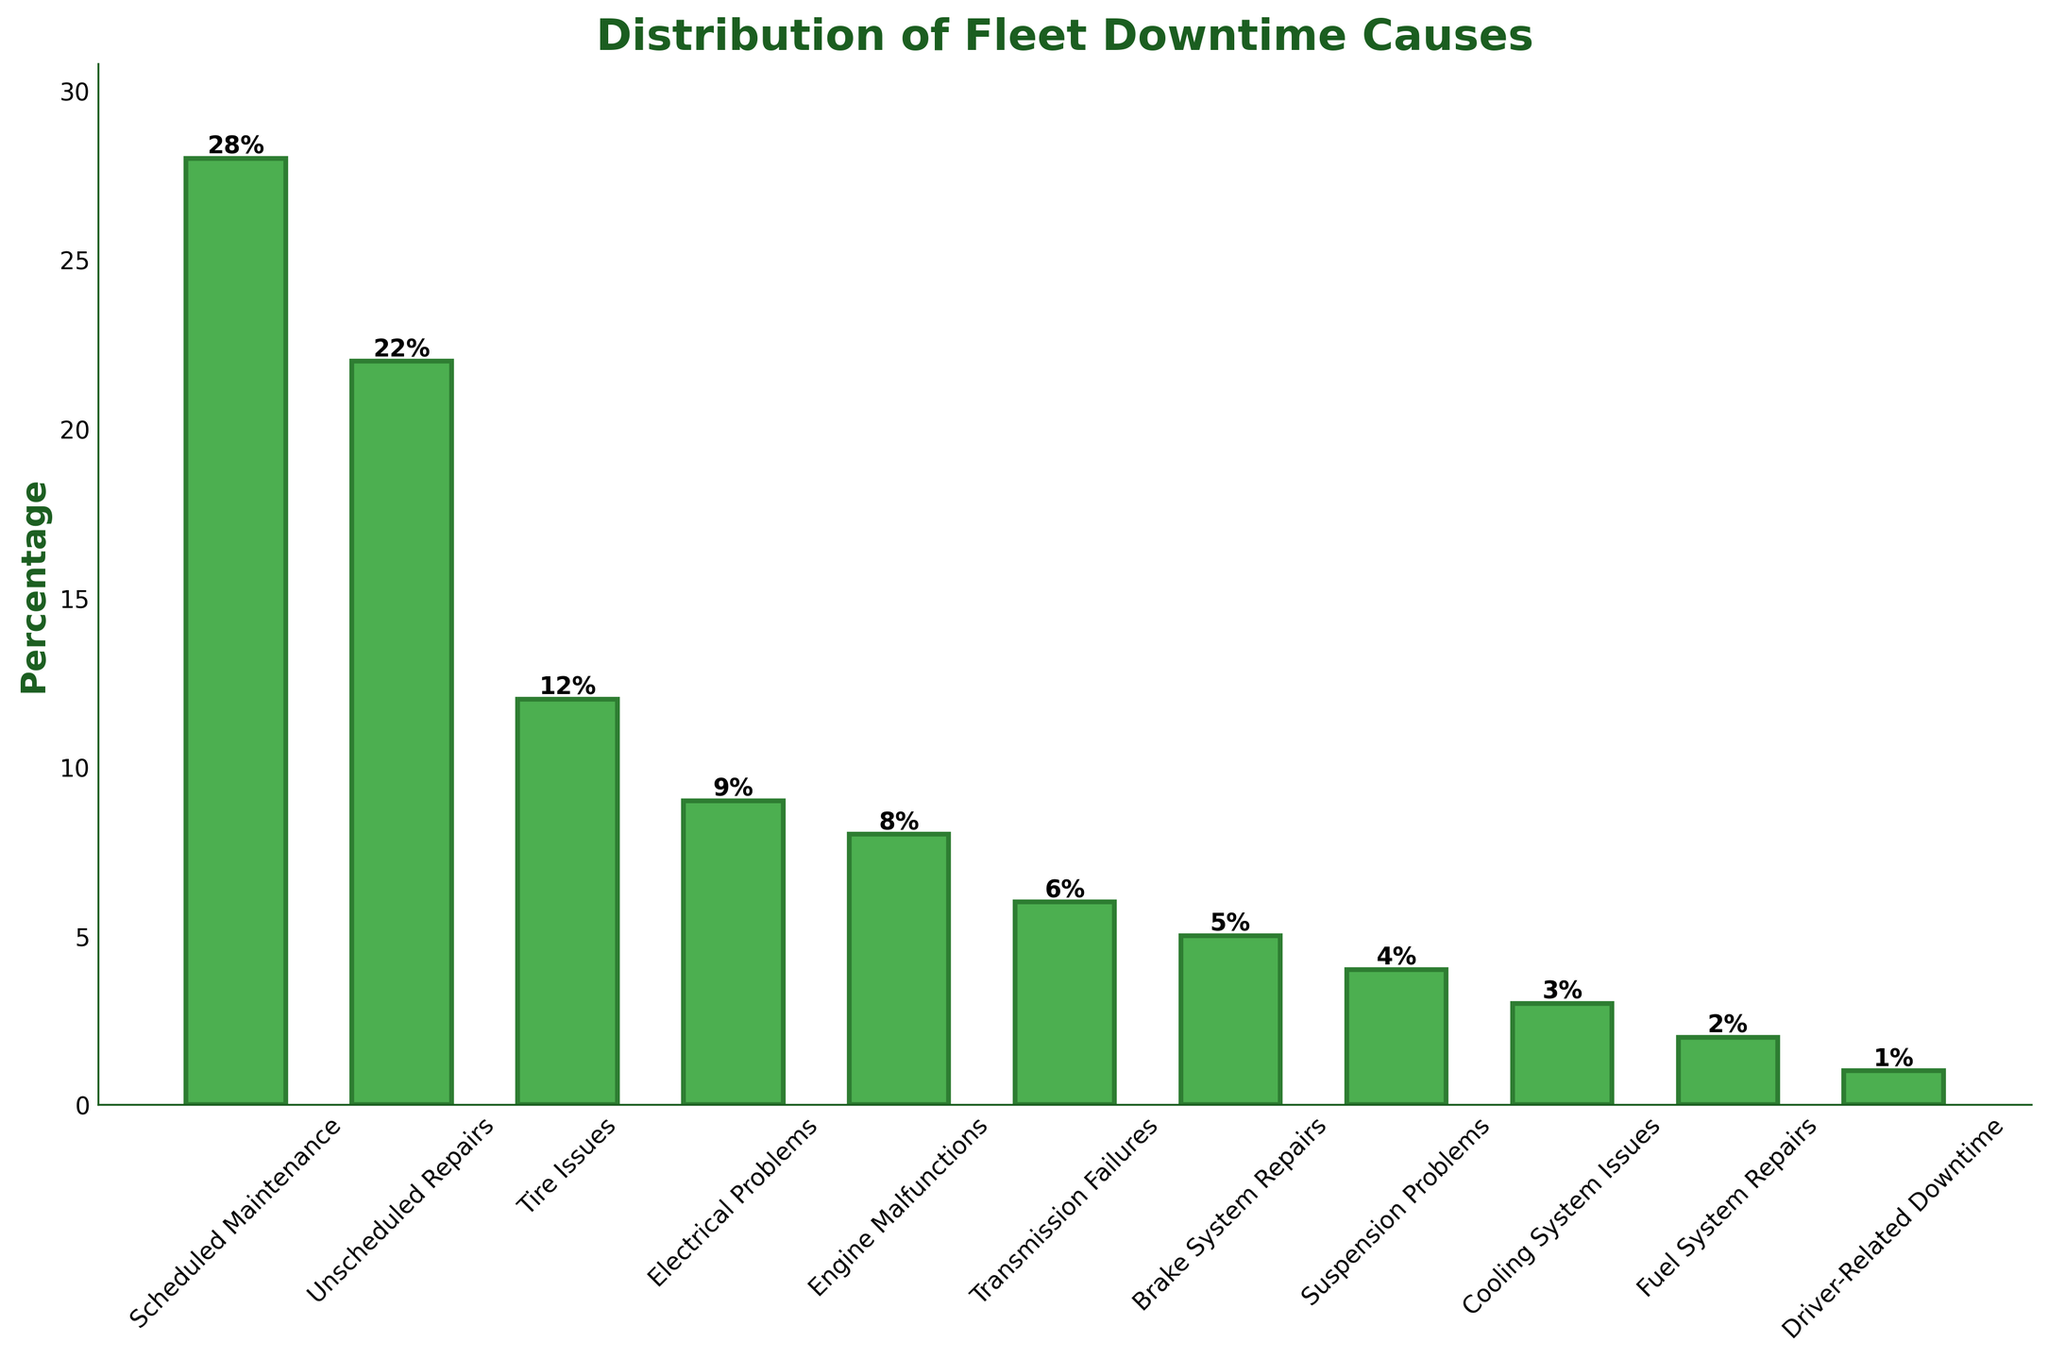Which cause has the highest percentage of fleet downtime? The bar representing "Scheduled Maintenance" is the tallest, indicating the highest percentage.
Answer: Scheduled Maintenance What's the difference in percentage between Scheduled Maintenance and Unscheduled Repairs? The percentage for Scheduled Maintenance is 28%, and for Unscheduled Repairs, it is 22%. The difference is 28% - 22%.
Answer: 6% How many causes have a downtime percentage equal to or less than 5%? Reading the bar lengths, we find that five causes (Brake System Repairs, Suspension Problems, Cooling System Issues, Fuel System Repairs, Driver-Related Downtime) have percentages of 5% or less.
Answer: 5 Which downtime cause is visually the shortest bar? By judging the relative heights of the bars, "Driver-Related Downtime" has the shortest bar.
Answer: Driver-Related Downtime What is the combined percentage of downtime due to Transmission Failures and Electrical Problems? Transmission Failures account for 6% and Electrical Problems for 9%. Summing them gives 6% + 9%.
Answer: 15% Compare the downtime percentage of Engine Malfunctions to Brake System Repairs. Which one is greater and by how much? Engine Malfunctions are at 8% and Brake System Repairs are at 5%. The difference is 8% - 5%.
Answer: Engine Malfunctions by 3% What is the average downtime percentage for the causes listed? Summing all the percentages (28 + 22 + 12 + 9 + 8 + 6 + 5 + 4 + 3 + 2 + 1 = 100) and dividing by the number of causes (11) gives 100/11.
Answer: 9.09% What percentage of downtime is attributed to tire issues? The figure shows that Tire Issues account for 12% of the downtime.
Answer: 12% Rank the causes from highest to lowest percentage. The figure lists the percentages in descending order: Scheduled Maintenance (28%), Unscheduled Repairs (22%), Tire Issues (12%), Electrical Problems (9%), Engine Malfunctions (8%), Transmission Failures (6%), Brake System Repairs (5%), Suspension Problems (4%), Cooling System Issues (3%), Fuel System Repairs (2%), Driver-Related Downtime (1%).
Answer: Scheduled Maintenance > Unscheduled Repairs > Tire Issues > Electrical Problems > Engine Malfunctions > Transmission Failures > Brake System Repairs > Suspension Problems > Cooling System Issues > Fuel System Repairs > Driver-Related Downtime If we were to reduce Scheduled Maintenance downtime by half, what would be its new percentage and position relative to other causes? Halving 28% gives 14%. It would then be higher than Electrical Problems (9%) but lower than Tire Issues (12%).
Answer: 14%, between Tire Issues and Electrical Problems 